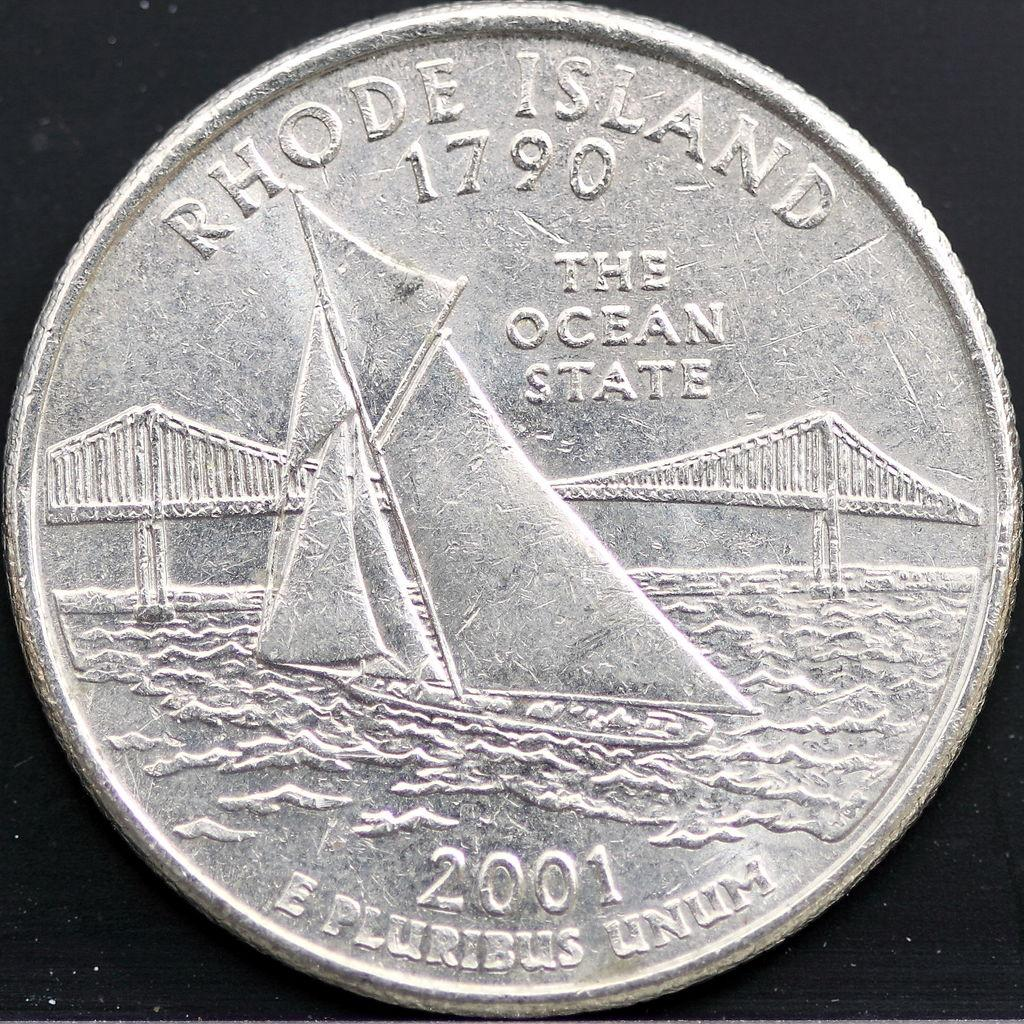<image>
Relay a brief, clear account of the picture shown. A sailboat and a bridge are pictured on the Rhode Island coin. 